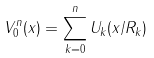<formula> <loc_0><loc_0><loc_500><loc_500>V _ { 0 } ^ { n } ( x ) = \sum _ { k = 0 } ^ { n } U _ { k } ( x / R _ { k } )</formula> 